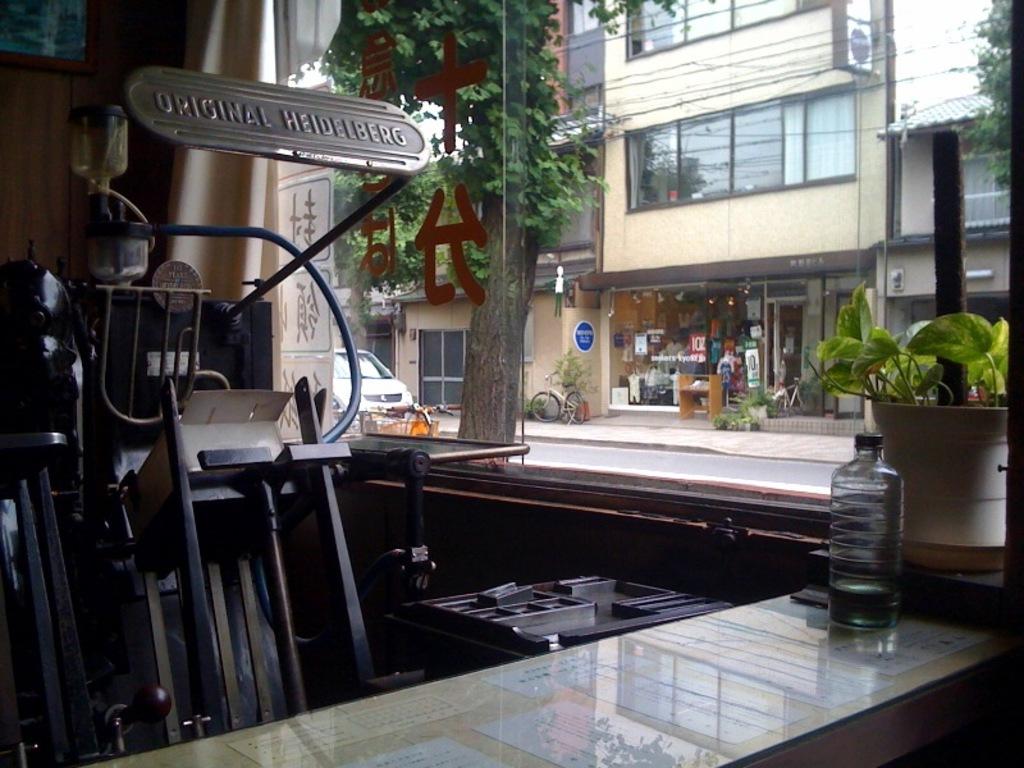What does the metal sign say?
Provide a short and direct response. Original heidelberg. 